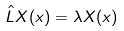<formula> <loc_0><loc_0><loc_500><loc_500>\hat { L } X ( x ) = \lambda X ( x )</formula> 